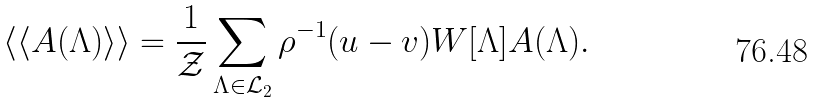<formula> <loc_0><loc_0><loc_500><loc_500>\langle \langle A ( \Lambda ) \rangle \rangle = \frac { 1 } { \mathcal { Z } } \sum _ { \Lambda \in \mathcal { L } _ { 2 } } \rho ^ { - 1 } ( u - v ) W [ \Lambda ] A ( \Lambda ) .</formula> 